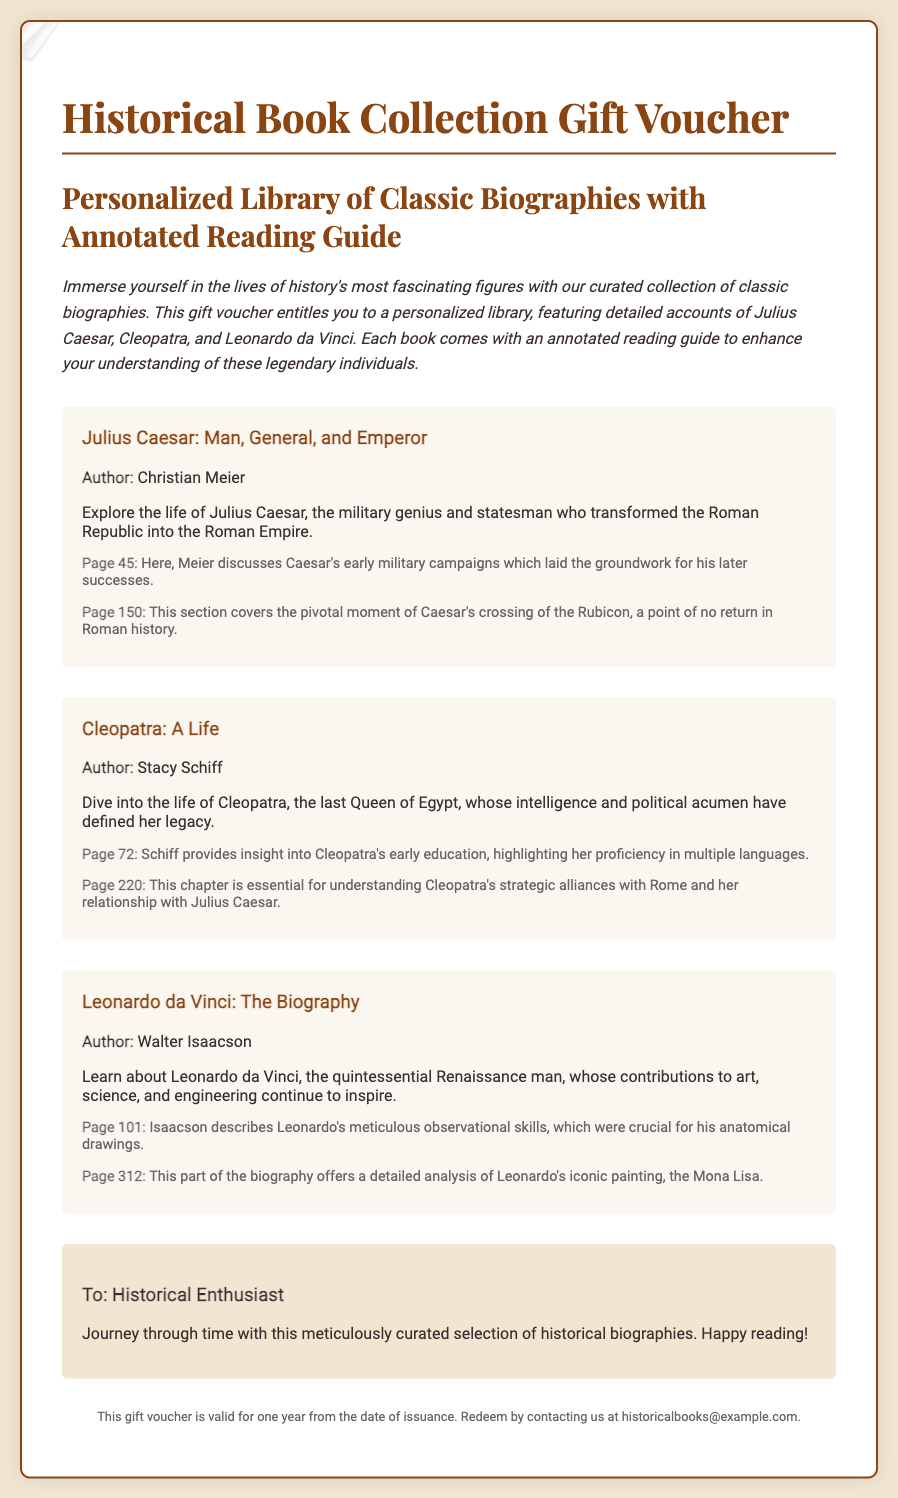what is the title of the gift voucher? The title is prominently displayed at the top of the document, indicating the type of gift being offered.
Answer: Historical Book Collection Gift Voucher who is the author of "Julius Caesar: Man, General, and Emperor"? Each book in the collection has the author's name listed immediately after the title.
Answer: Christian Meier what is Cleopatra known for in this voucher? The document provides a brief description of Cleopatra’s attributes and historical significance after mentioning her title.
Answer: intelligence and political acumen how many pages does the biography "Leonardo da Vinci: The Biography" have? The document references page numbers where specific information can be found but does not provide a total page count.
Answer: Not specified who is the intended recipient of the voucher? The personalization section indicates who the voucher is tailored for, which is a historical enthusiast.
Answer: Historical Enthusiast what is the main theme of the biographies listed? Each biography represents a significant historical figure, and the introductory paragraph sets the tone for the historical exploration.
Answer: Lives of history's most fascinating figures what is included with each book in the collection? The introduction describes an additional feature that enhances the reading experience for the user.
Answer: Annotated reading guide how long is the voucher valid for? The footer of the document specifies how long the voucher can be used after it is issued.
Answer: One year from the date of issuance what type of document is this? The overall structure and content of the voucher suggest its purpose and intended use.
Answer: Gift voucher 